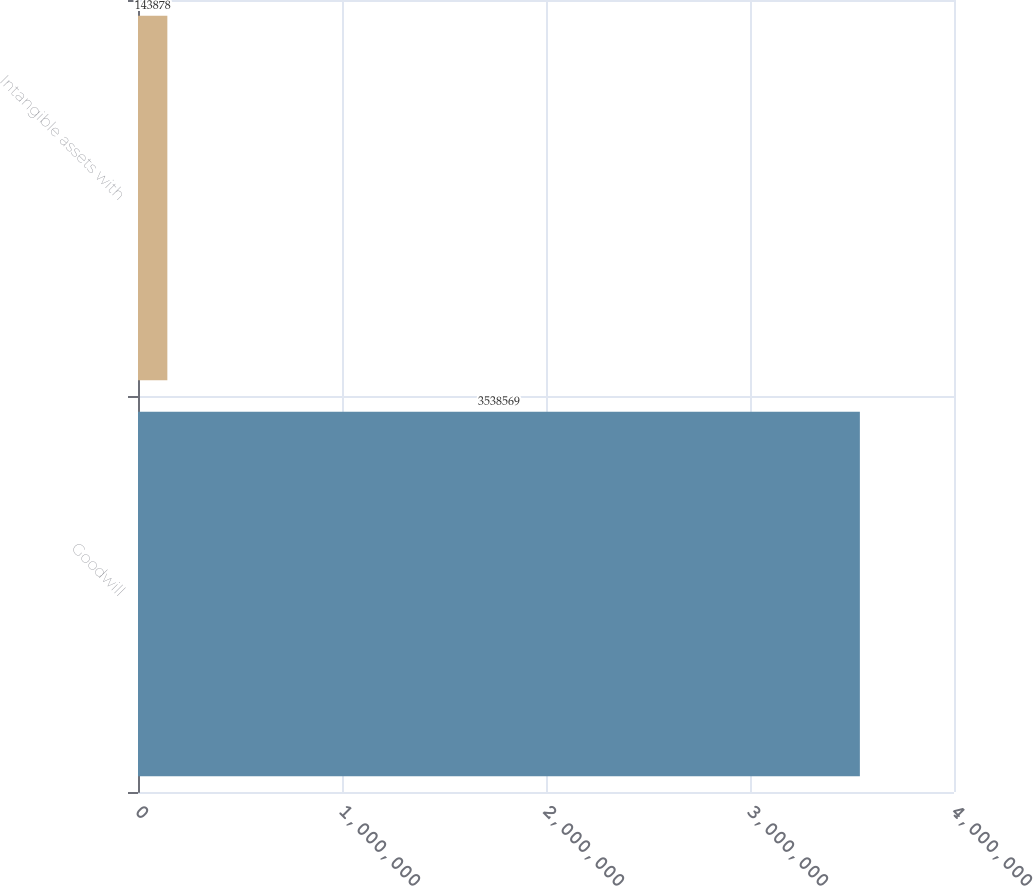<chart> <loc_0><loc_0><loc_500><loc_500><bar_chart><fcel>Goodwill<fcel>Intangible assets with<nl><fcel>3.53857e+06<fcel>143878<nl></chart> 